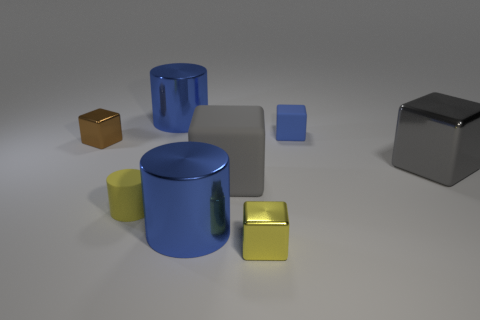What material is the big cube that is right of the tiny block in front of the yellow matte cylinder?
Offer a terse response. Metal. How many metal things are big cyan cylinders or small blue things?
Provide a short and direct response. 0. Is there anything else that has the same material as the blue block?
Give a very brief answer. Yes. Is there a big block left of the yellow object in front of the small yellow cylinder?
Your answer should be compact. Yes. How many things are things that are left of the small blue rubber thing or cylinders that are behind the brown cube?
Ensure brevity in your answer.  6. Is there any other thing that has the same color as the big matte thing?
Give a very brief answer. Yes. What is the color of the metal thing behind the tiny blue thing on the right side of the tiny yellow object to the right of the tiny yellow cylinder?
Give a very brief answer. Blue. There is a brown metal cube that is to the left of the blue object that is in front of the tiny brown block; how big is it?
Keep it short and to the point. Small. What is the large thing that is both to the left of the gray matte thing and in front of the blue cube made of?
Provide a succinct answer. Metal. Does the brown shiny block have the same size as the gray thing in front of the large gray metal thing?
Ensure brevity in your answer.  No. 